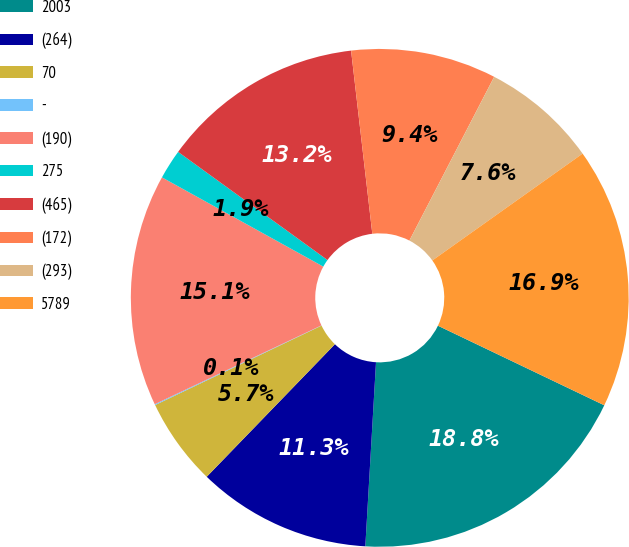<chart> <loc_0><loc_0><loc_500><loc_500><pie_chart><fcel>2003<fcel>(264)<fcel>70<fcel>-<fcel>(190)<fcel>275<fcel>(465)<fcel>(172)<fcel>(293)<fcel>5789<nl><fcel>18.82%<fcel>11.31%<fcel>5.68%<fcel>0.06%<fcel>15.07%<fcel>1.93%<fcel>13.19%<fcel>9.44%<fcel>7.56%<fcel>16.94%<nl></chart> 